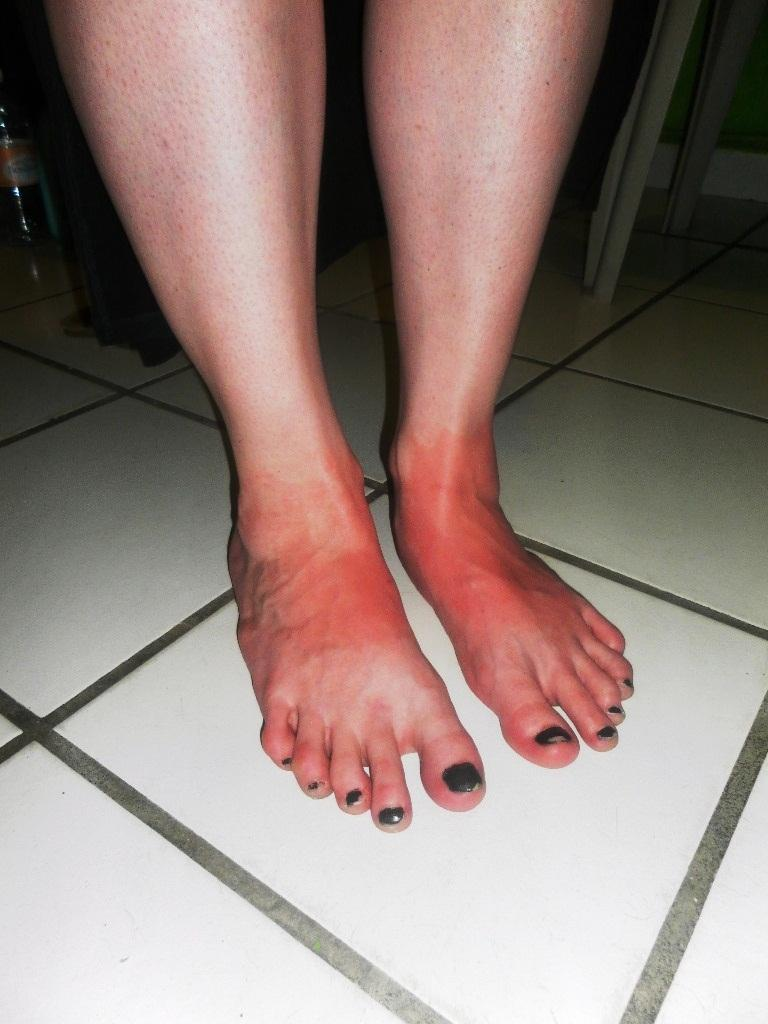What part of a person or animal can be seen in the image? There are legs visible in the image. Can you describe what is visible in the background of the image? Unfortunately, the provided facts do not give any specific details about the objects in the background. How many pizzas are being compared by the horse in the image? There is no horse or pizzas present in the image. What type of comparison is the horse making between the pizzas in the image? There is no horse or pizzas present in the image, so it is not possible to answer that question. 